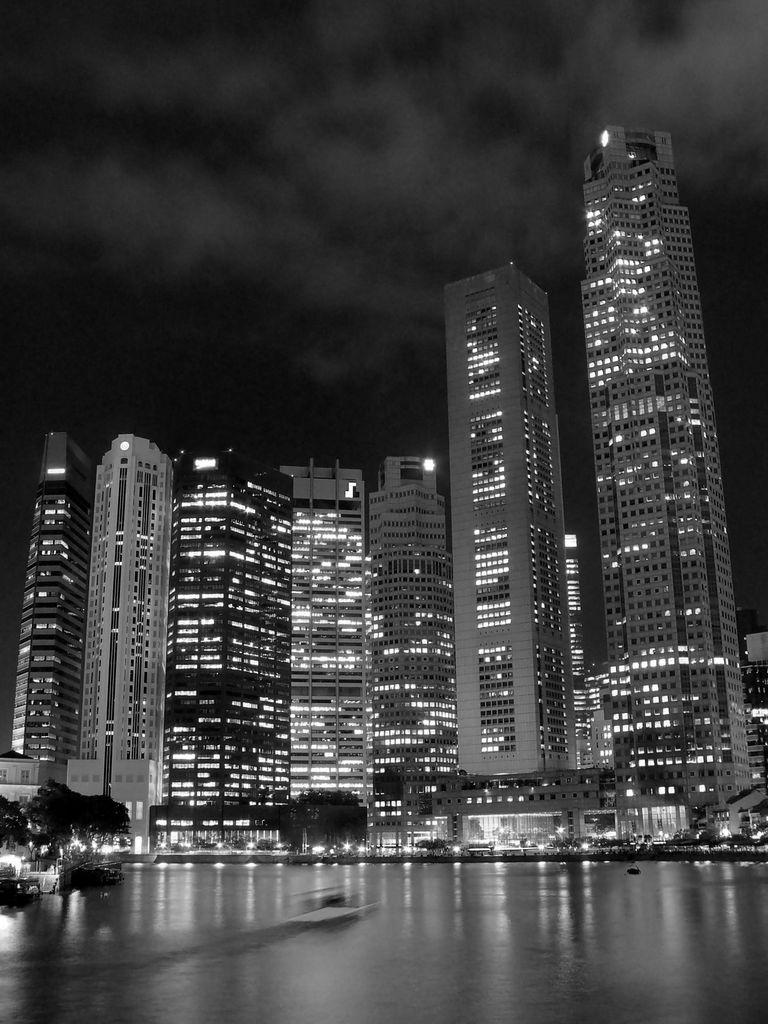Can you describe this image briefly? These are the very big buildings with lights, at the top it's a night sky. 